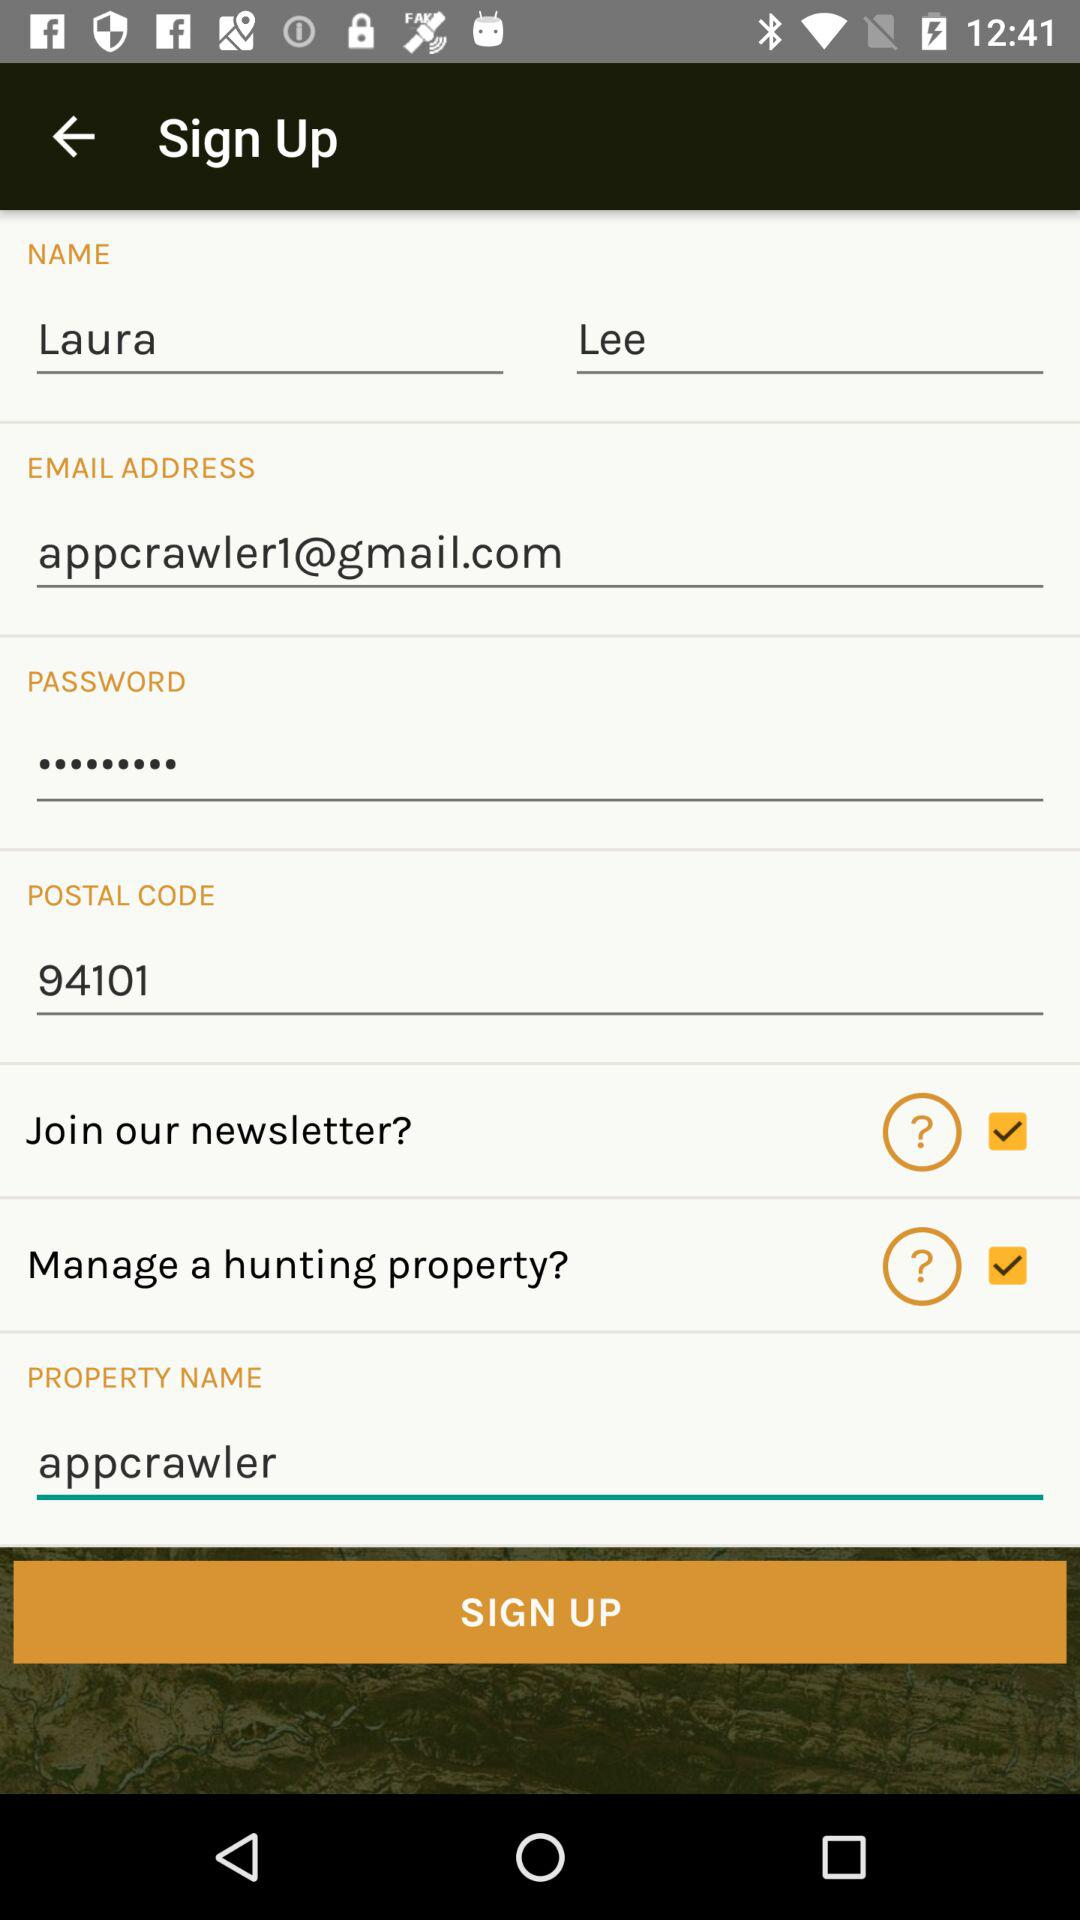What is the property name? The property name is "appcrawler". 